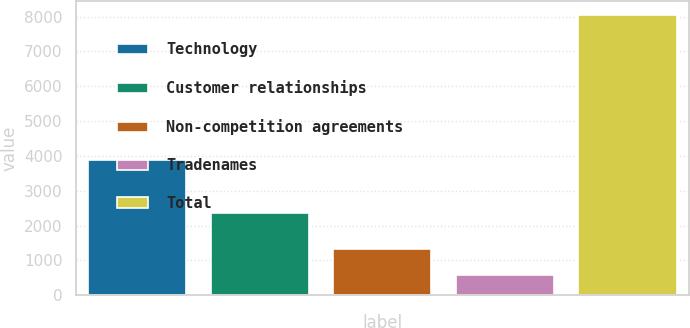Convert chart to OTSL. <chart><loc_0><loc_0><loc_500><loc_500><bar_chart><fcel>Technology<fcel>Customer relationships<fcel>Non-competition agreements<fcel>Tradenames<fcel>Total<nl><fcel>3892<fcel>2364<fcel>1317<fcel>570<fcel>8040<nl></chart> 